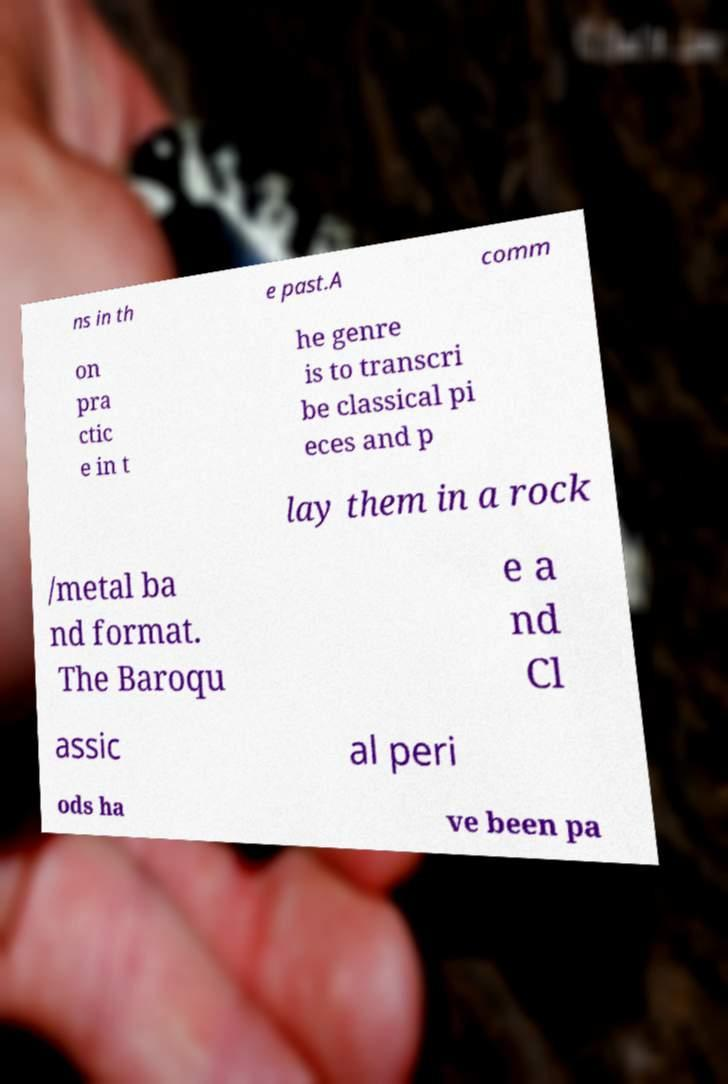There's text embedded in this image that I need extracted. Can you transcribe it verbatim? ns in th e past.A comm on pra ctic e in t he genre is to transcri be classical pi eces and p lay them in a rock /metal ba nd format. The Baroqu e a nd Cl assic al peri ods ha ve been pa 